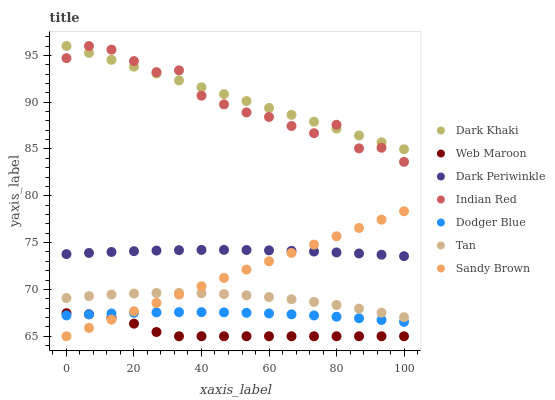Does Web Maroon have the minimum area under the curve?
Answer yes or no. Yes. Does Dark Khaki have the maximum area under the curve?
Answer yes or no. Yes. Does Dodger Blue have the minimum area under the curve?
Answer yes or no. No. Does Dodger Blue have the maximum area under the curve?
Answer yes or no. No. Is Dark Khaki the smoothest?
Answer yes or no. Yes. Is Indian Red the roughest?
Answer yes or no. Yes. Is Dodger Blue the smoothest?
Answer yes or no. No. Is Dodger Blue the roughest?
Answer yes or no. No. Does Web Maroon have the lowest value?
Answer yes or no. Yes. Does Dodger Blue have the lowest value?
Answer yes or no. No. Does Dark Khaki have the highest value?
Answer yes or no. Yes. Does Dodger Blue have the highest value?
Answer yes or no. No. Is Tan less than Dark Periwinkle?
Answer yes or no. Yes. Is Dark Periwinkle greater than Web Maroon?
Answer yes or no. Yes. Does Sandy Brown intersect Dark Periwinkle?
Answer yes or no. Yes. Is Sandy Brown less than Dark Periwinkle?
Answer yes or no. No. Is Sandy Brown greater than Dark Periwinkle?
Answer yes or no. No. Does Tan intersect Dark Periwinkle?
Answer yes or no. No. 